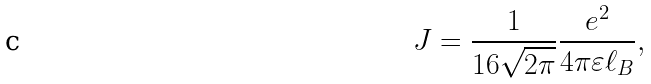<formula> <loc_0><loc_0><loc_500><loc_500>J = \frac { 1 } { 1 6 \sqrt { 2 \pi } } \frac { e ^ { 2 } } { 4 \pi \varepsilon \ell _ { B } } ,</formula> 